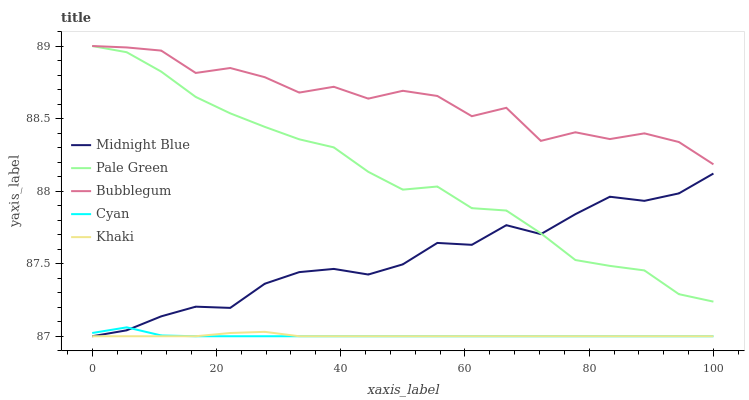Does Pale Green have the minimum area under the curve?
Answer yes or no. No. Does Pale Green have the maximum area under the curve?
Answer yes or no. No. Is Pale Green the smoothest?
Answer yes or no. No. Is Pale Green the roughest?
Answer yes or no. No. Does Pale Green have the lowest value?
Answer yes or no. No. Does Khaki have the highest value?
Answer yes or no. No. Is Khaki less than Bubblegum?
Answer yes or no. Yes. Is Bubblegum greater than Midnight Blue?
Answer yes or no. Yes. Does Khaki intersect Bubblegum?
Answer yes or no. No. 